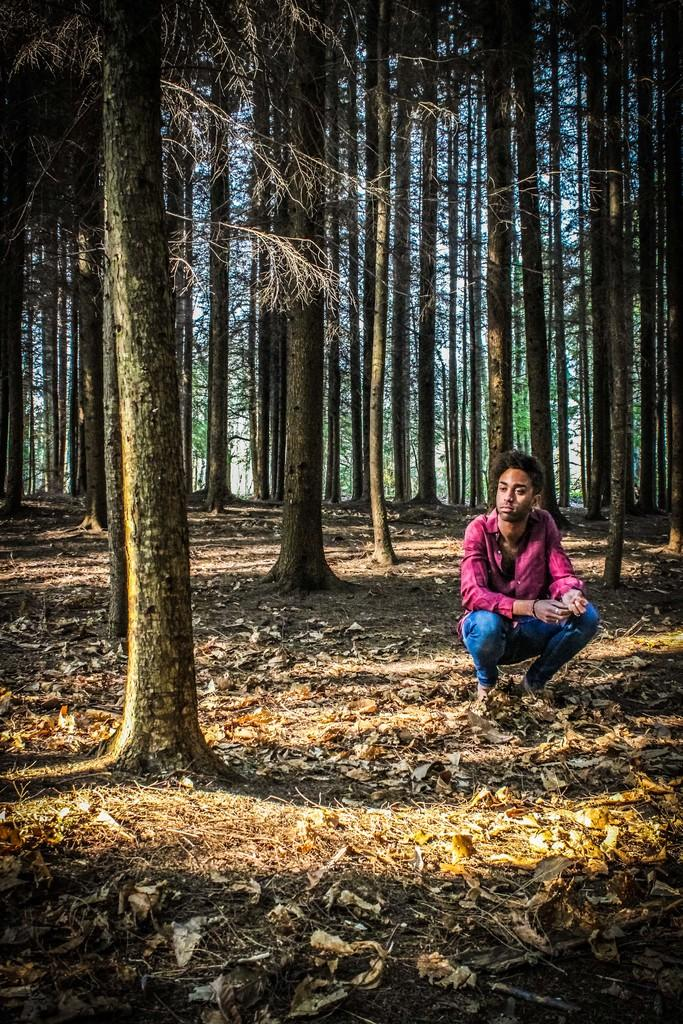What can be seen in the foreground of the picture? In the foreground of the picture, there are dry leaves, grass, trees, and a person. What type of vegetation is present in the foreground? There is grass and trees in the foreground of the picture. Can you describe the person in the foreground? There is a person in the foreground of the picture, but their appearance or actions are not specified. What is visible in the background of the picture? In the background of the picture, there are trees. What type of chair can be seen in the picture? There is no chair present in the picture. Can you hear the voice of the person in the picture? The image is silent, so it is not possible to hear the voice of the person in the picture. 